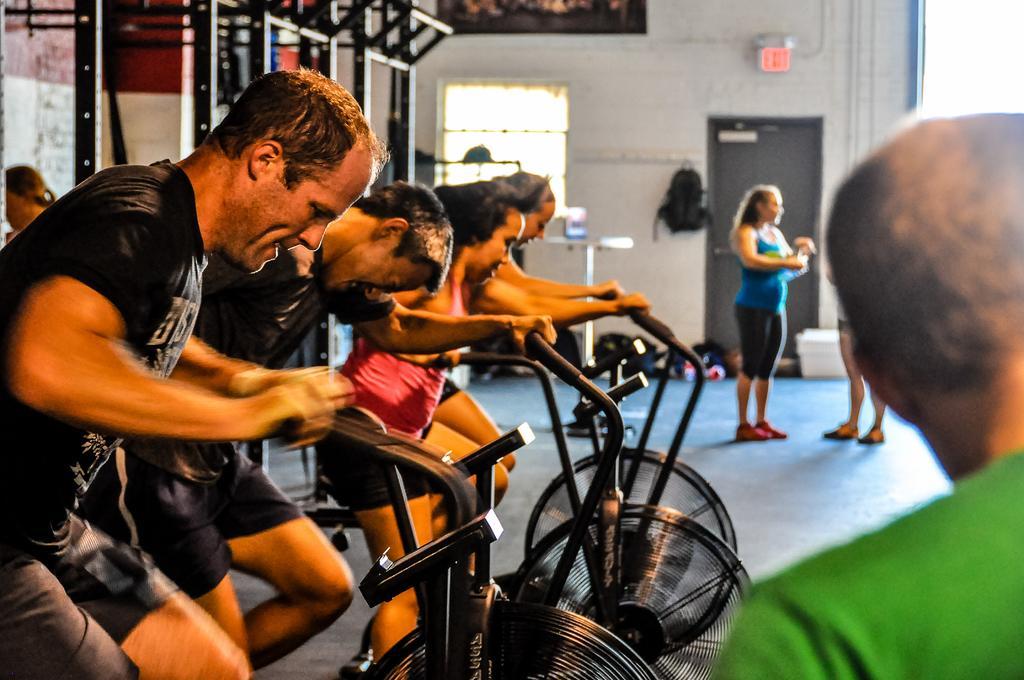Could you give a brief overview of what you see in this image? In this image there are so many people cycling in the gym, beside them there are so other gym equipment and some other people standing on the floor. 